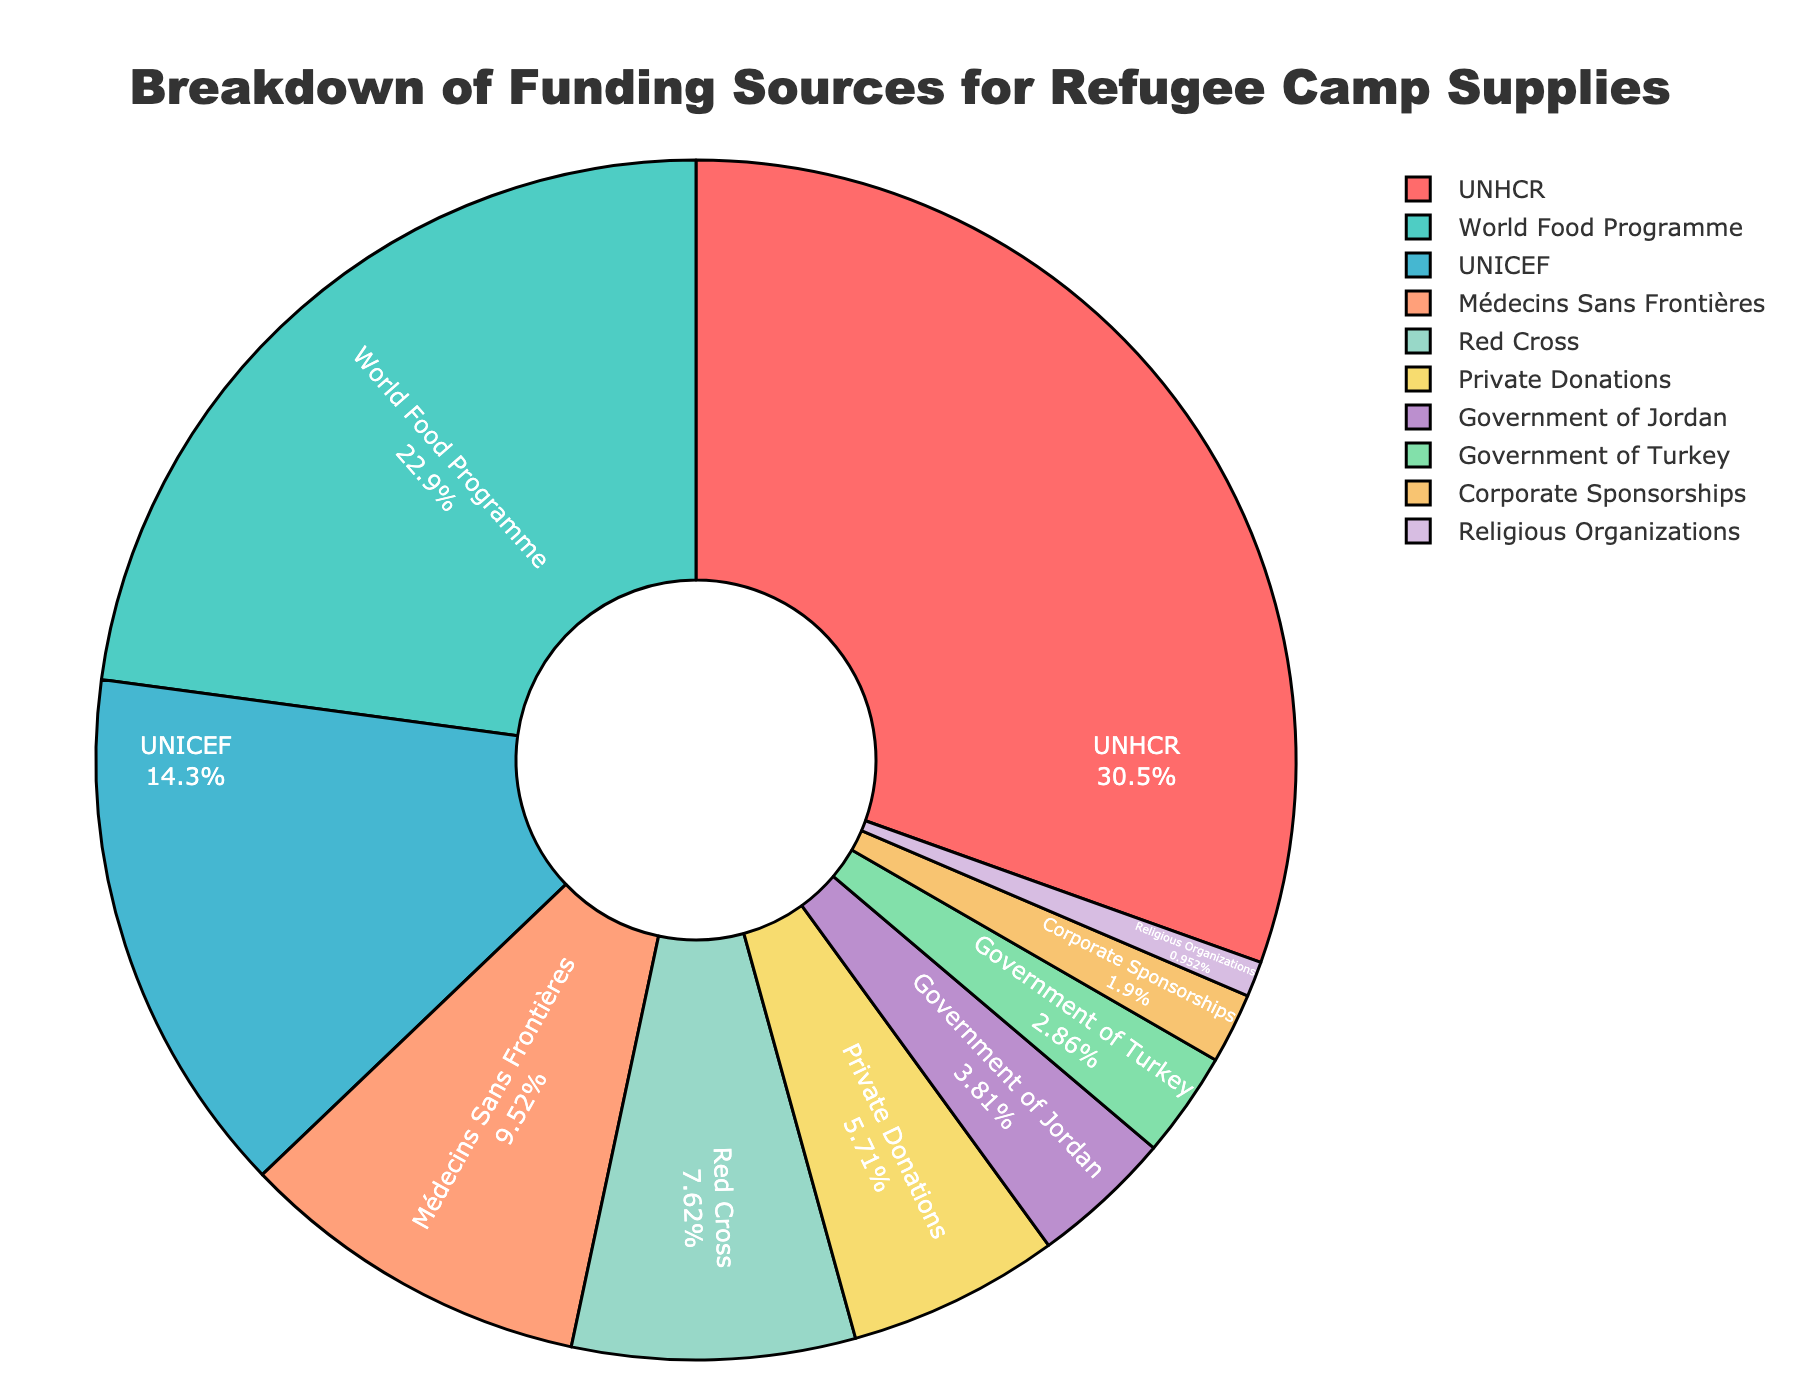What is the largest funding source for refugee camp supplies? Identify the segment with the highest percentage. The pie chart shows that the UNHCR segment is labeled with the highest percentage at 32%.
Answer: UNHCR Which funding source contributes more: UNICEF or Médecins Sans Frontières? Compare the percentages of UNICEF and Médecins Sans Frontières. UNICEF contributes 15%, while Médecins Sans Frontières contributes 10%, so UNICEF contributes more.
Answer: UNICEF What is the combined percentage contribution of the Red Cross and Private Donations? Sum the percentages of Red Cross (8%) and Private Donations (6%). The combined percentage is 8% + 6% = 14%.
Answer: 14% How does the percentage contribution of the World Food Programme compare to that of the Government of Jordan? Compare the percentages. World Food Programme contributes 24%, whereas the Government of Jordan contributes 4%. Therefore, the World Food Programme contributes 20% more.
Answer: 20% more Which funding source has the smallest contribution? Identify the segment with the smallest percentage. The pie chart shows that Religious Organizations have the smallest contribution at 1%.
Answer: Religious Organizations Which funding sources contribute less than 5%? List funding sources with contributions under 5%. The sources are Government of Jordan (4%), Government of Turkey (3%), Corporate Sponsorships (2%), and Religious Organizations (1%).
Answer: Government of Jordan, Government of Turkey, Corporate Sponsorships, Religious Organizations If Private Donations and Corporate Sponsorships are combined, what would be their total percentage contribution? Sum the percentages of Private Donations (6%) and Corporate Sponsorships (2%). The combined total is 6% + 2% = 8%.
Answer: 8% Is the contribution from NGOs (Red Cross and Médecins Sans Frontières) greater than that from UNICEF? Sum the contributions from Red Cross (8%) and Médecins Sans Frontières (10%) which equals 18%. Compare this to UNICEF which contributes 15%. Yes, NGOs contribute more (18% compared to 15%).
Answer: Yes What is the difference in percentage between the highest and lowest contributing sources? Subtract the smallest percentage (Religious Organizations at 1%) from the largest percentage (UNHCR at 32%). The difference is 32% - 1% = 31%.
Answer: 31% How does the contribution of Private Donations compare to that of the Government of Turkey? Compare the percentages. Private Donations contribute 6%, whereas the Government of Turkey contributes 3%. Therefore, Private Donations contribute 3% more.
Answer: 3% more 